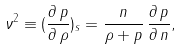<formula> <loc_0><loc_0><loc_500><loc_500>\nu ^ { 2 } \equiv ( \frac { \partial \, p } { \partial \, \rho } ) _ { s } = \frac { n } { \rho + p } \, \frac { \partial \, p } { \partial \, n } ,</formula> 